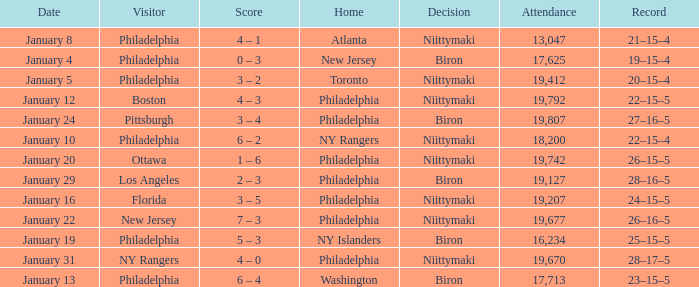What was the date that the decision was Niittymaki, the attendance larger than 19,207, and the record 28–17–5? January 31. 